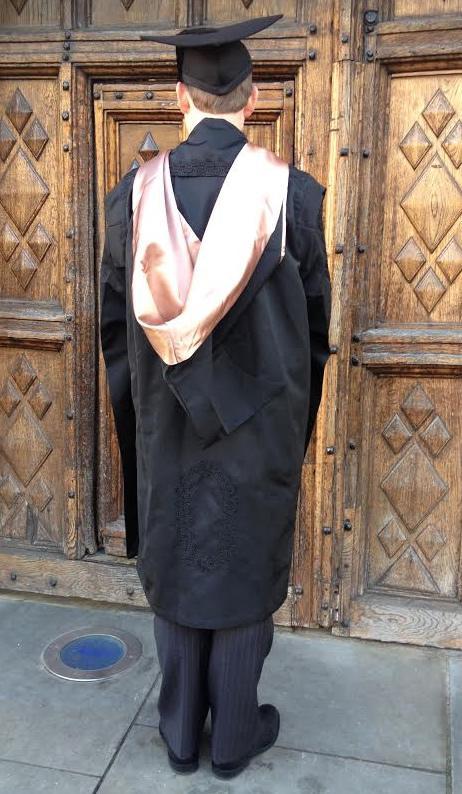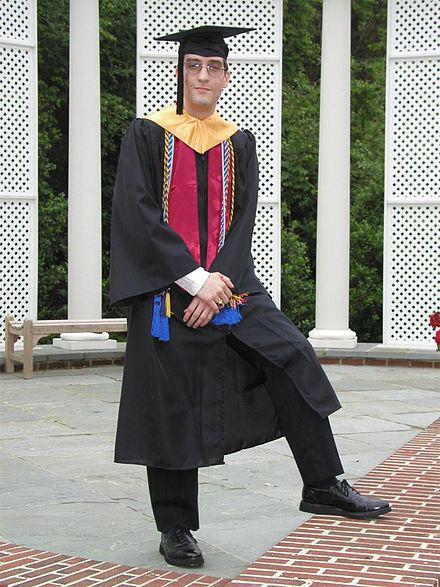The first image is the image on the left, the second image is the image on the right. Assess this claim about the two images: "Each image shows a real person modeling graduation attire, with one image showing a front view and the other image showing a rear view.". Correct or not? Answer yes or no. Yes. The first image is the image on the left, the second image is the image on the right. Given the left and right images, does the statement "The graduation attire in one of the images is draped over a mannequin." hold true? Answer yes or no. No. 